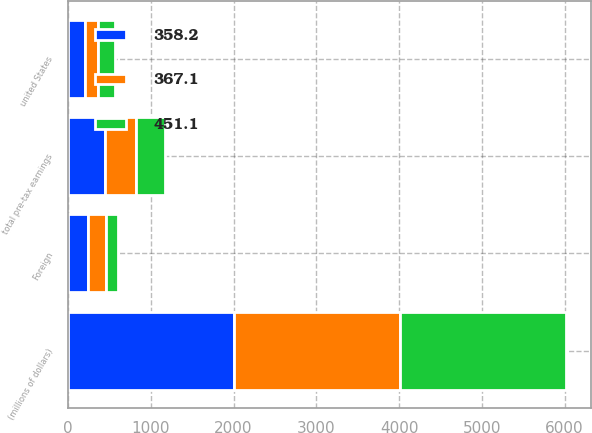Convert chart to OTSL. <chart><loc_0><loc_0><loc_500><loc_500><stacked_bar_chart><ecel><fcel>(millions of dollars)<fcel>united States<fcel>Foreign<fcel>total pre-tax earnings<nl><fcel>358.2<fcel>2007<fcel>206.9<fcel>244.2<fcel>451.1<nl><fcel>367.1<fcel>2006<fcel>150.7<fcel>216.4<fcel>367.1<nl><fcel>451.1<fcel>2005<fcel>210.2<fcel>148<fcel>358.2<nl></chart> 